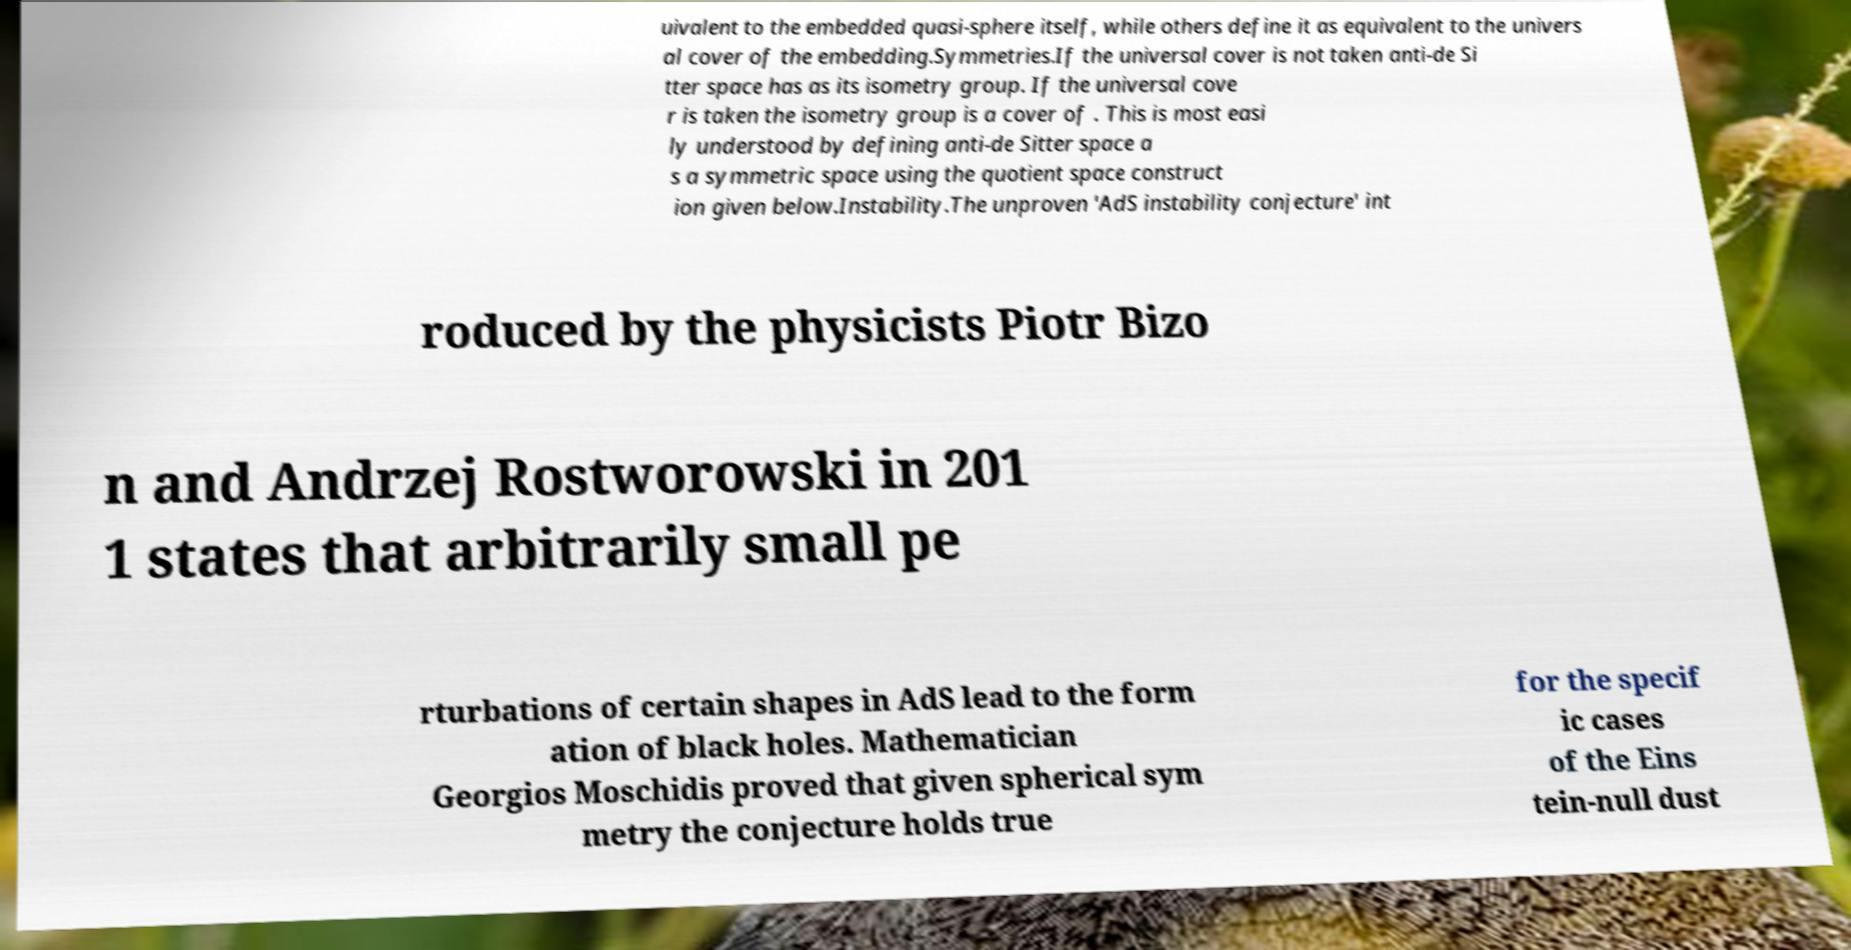There's text embedded in this image that I need extracted. Can you transcribe it verbatim? uivalent to the embedded quasi-sphere itself, while others define it as equivalent to the univers al cover of the embedding.Symmetries.If the universal cover is not taken anti-de Si tter space has as its isometry group. If the universal cove r is taken the isometry group is a cover of . This is most easi ly understood by defining anti-de Sitter space a s a symmetric space using the quotient space construct ion given below.Instability.The unproven 'AdS instability conjecture' int roduced by the physicists Piotr Bizo n and Andrzej Rostworowski in 201 1 states that arbitrarily small pe rturbations of certain shapes in AdS lead to the form ation of black holes. Mathematician Georgios Moschidis proved that given spherical sym metry the conjecture holds true for the specif ic cases of the Eins tein-null dust 